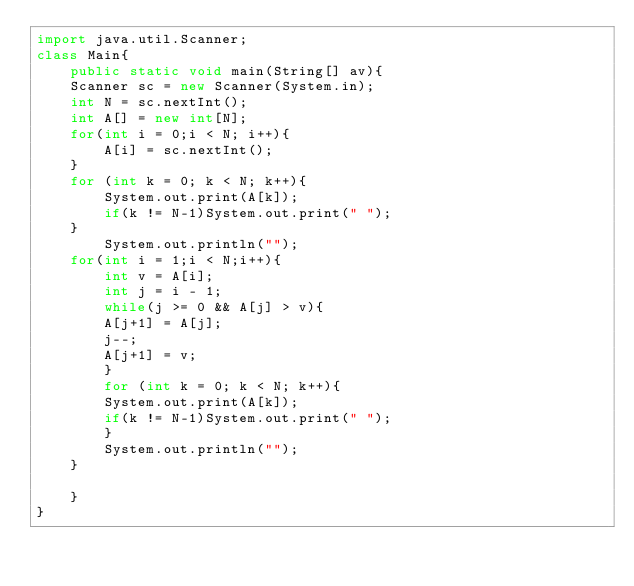<code> <loc_0><loc_0><loc_500><loc_500><_Java_>import java.util.Scanner;
class Main{
    public static void main(String[] av){
	Scanner sc = new Scanner(System.in);
	int N = sc.nextInt(); 
	int A[] = new int[N];
	for(int i = 0;i < N; i++){
	    A[i] = sc.nextInt(); 
	}
    for (int k = 0; k < N; k++){
		System.out.print(A[k]);
		if(k != N-1)System.out.print(" ");
    }   
	    System.out.println("");
	for(int i = 1;i < N;i++){
	    int v = A[i];
	    int j = i - 1;
	    while(j >= 0 && A[j] > v){
		A[j+1] = A[j];
		j--;
		A[j+1] = v;
	    }
	    for (int k = 0; k < N; k++){
		System.out.print(A[k]);
		if(k != N-1)System.out.print(" ");
	    }
	    System.out.println("");
	}
	    
    }
}
</code> 